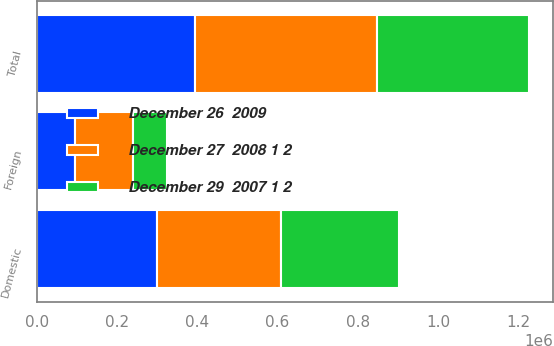<chart> <loc_0><loc_0><loc_500><loc_500><stacked_bar_chart><ecel><fcel>Domestic<fcel>Foreign<fcel>Total<nl><fcel>December 27  2008 1 2<fcel>308238<fcel>144482<fcel>452720<nl><fcel>December 26  2009<fcel>300227<fcel>95222<fcel>395449<nl><fcel>December 29  2007 1 2<fcel>293851<fcel>84658<fcel>378509<nl></chart> 